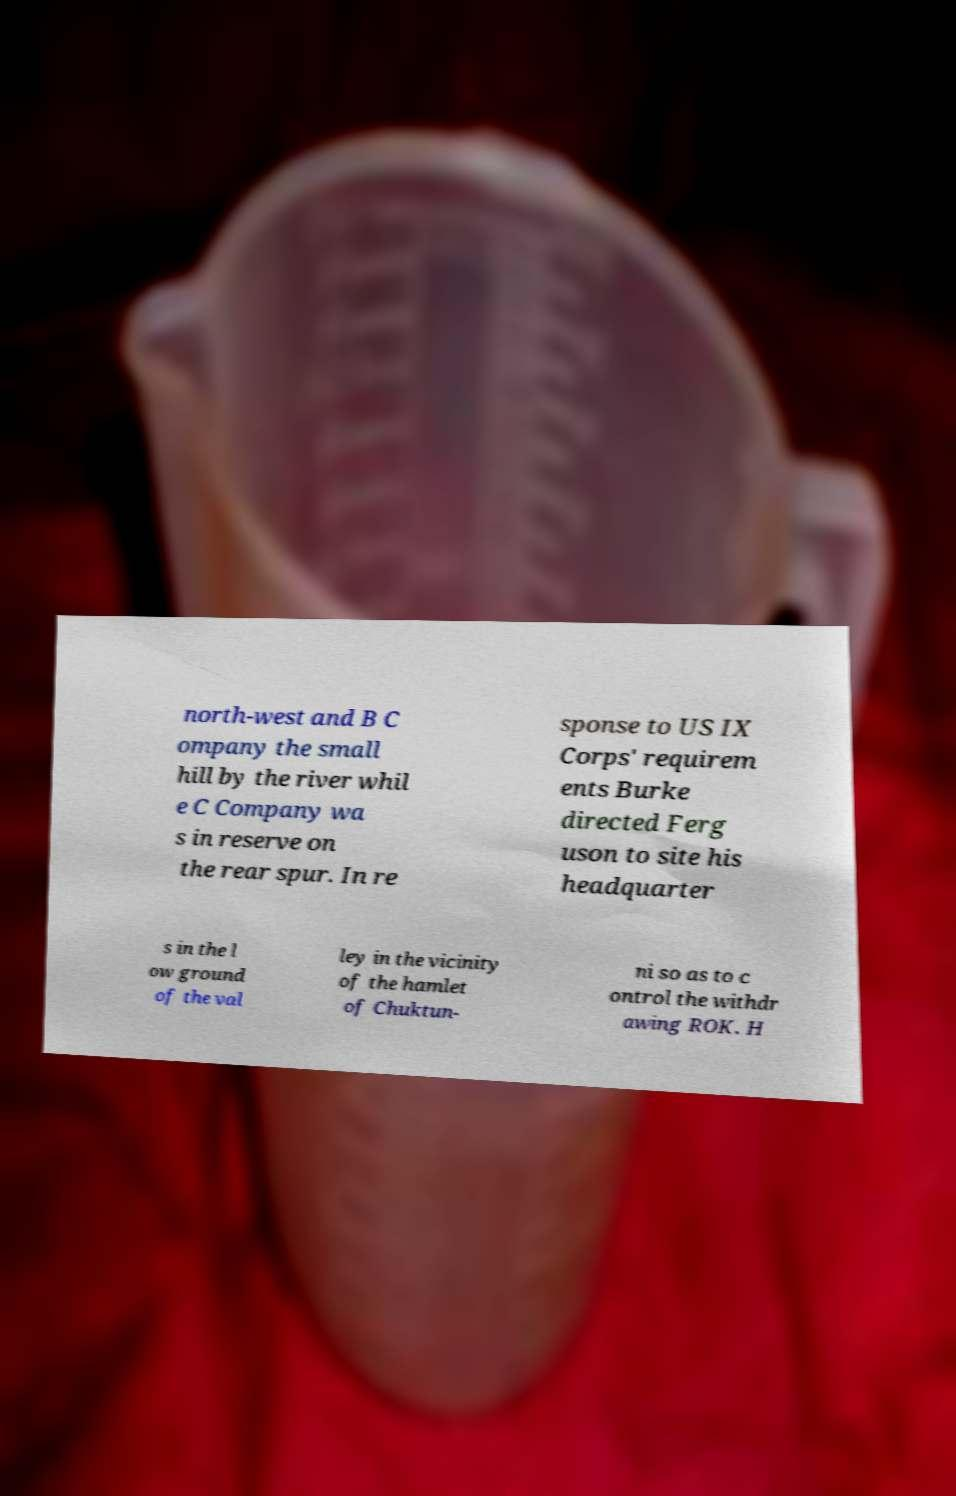Could you extract and type out the text from this image? north-west and B C ompany the small hill by the river whil e C Company wa s in reserve on the rear spur. In re sponse to US IX Corps' requirem ents Burke directed Ferg uson to site his headquarter s in the l ow ground of the val ley in the vicinity of the hamlet of Chuktun- ni so as to c ontrol the withdr awing ROK. H 